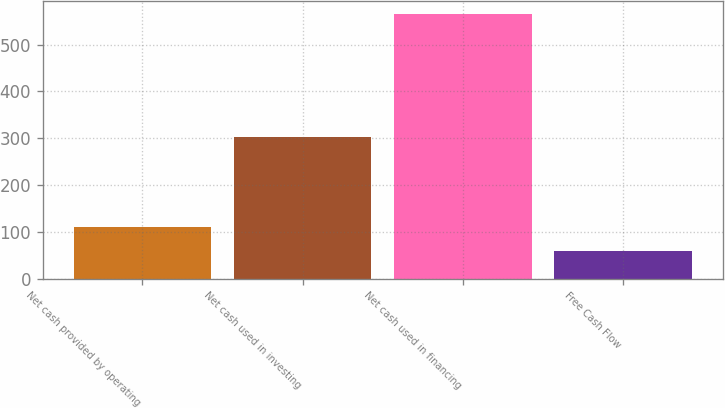Convert chart to OTSL. <chart><loc_0><loc_0><loc_500><loc_500><bar_chart><fcel>Net cash provided by operating<fcel>Net cash used in investing<fcel>Net cash used in financing<fcel>Free Cash Flow<nl><fcel>110.12<fcel>303<fcel>565.7<fcel>59.5<nl></chart> 